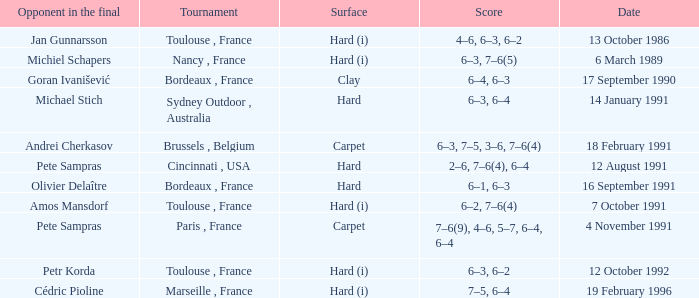What is the surface of the tournament with cédric pioline as the opponent in the final? Hard (i). 